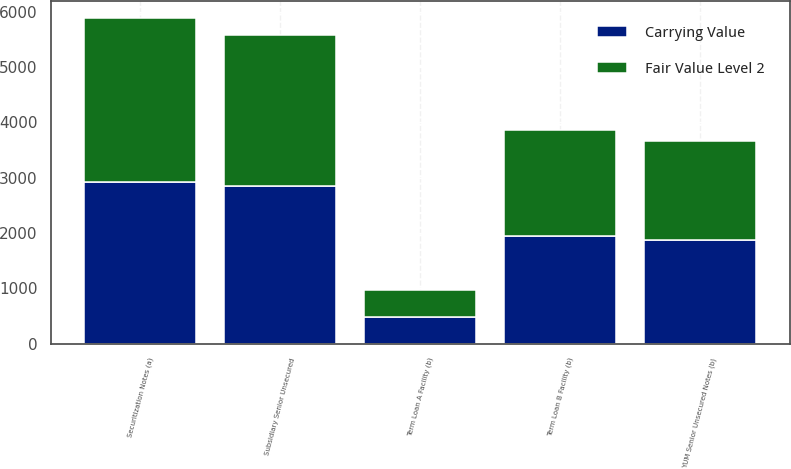Convert chart to OTSL. <chart><loc_0><loc_0><loc_500><loc_500><stacked_bar_chart><ecel><fcel>Securitization Notes (a)<fcel>Subsidiary Senior Unsecured<fcel>Term Loan A Facility (b)<fcel>Term Loan B Facility (b)<fcel>YUM Senior Unsecured Notes (b)<nl><fcel>Carrying Value<fcel>2928<fcel>2850<fcel>488<fcel>1955<fcel>1875<nl><fcel>Fair Value Level 2<fcel>2967<fcel>2733<fcel>479<fcel>1915<fcel>1798<nl></chart> 